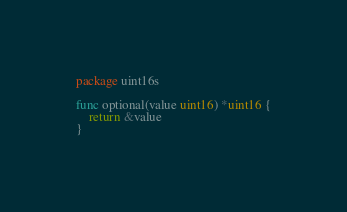Convert code to text. <code><loc_0><loc_0><loc_500><loc_500><_Go_>package uint16s

func optional(value uint16) *uint16 {
	return &value
}
</code> 